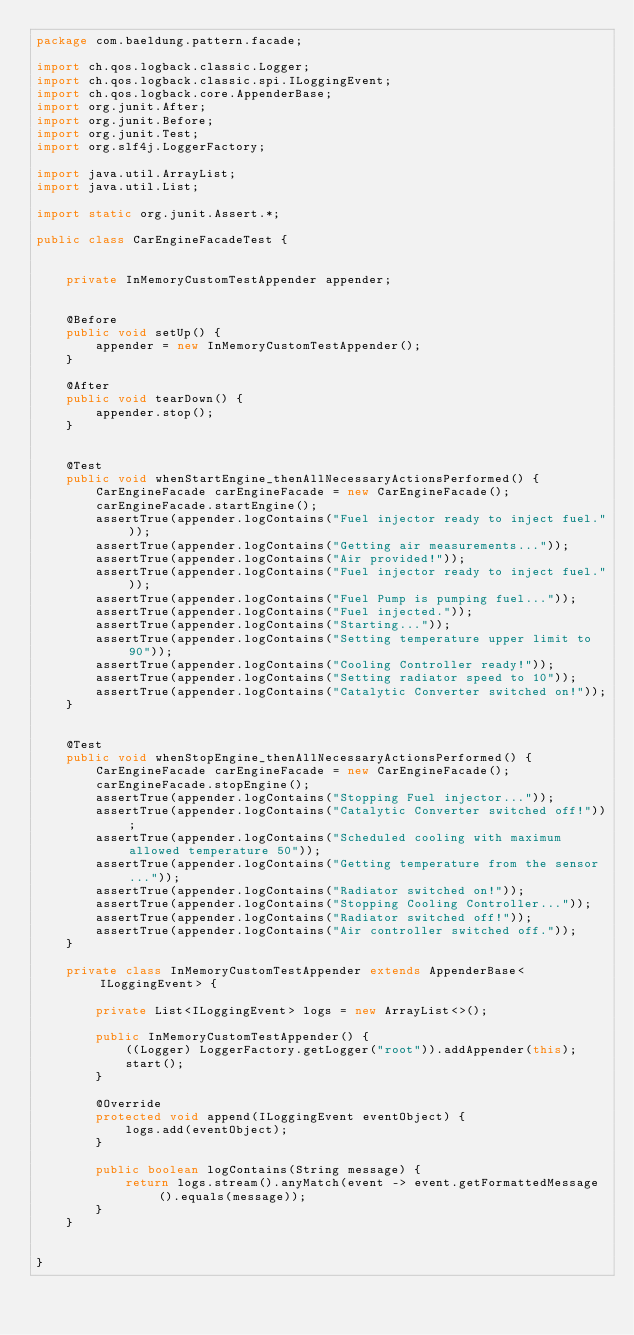<code> <loc_0><loc_0><loc_500><loc_500><_Java_>package com.baeldung.pattern.facade;

import ch.qos.logback.classic.Logger;
import ch.qos.logback.classic.spi.ILoggingEvent;
import ch.qos.logback.core.AppenderBase;
import org.junit.After;
import org.junit.Before;
import org.junit.Test;
import org.slf4j.LoggerFactory;

import java.util.ArrayList;
import java.util.List;

import static org.junit.Assert.*;

public class CarEngineFacadeTest {


    private InMemoryCustomTestAppender appender;


    @Before
    public void setUp() {
        appender = new InMemoryCustomTestAppender();
    }

    @After
    public void tearDown() {
        appender.stop();
    }


    @Test
    public void whenStartEngine_thenAllNecessaryActionsPerformed() {
        CarEngineFacade carEngineFacade = new CarEngineFacade();
        carEngineFacade.startEngine();
        assertTrue(appender.logContains("Fuel injector ready to inject fuel."));
        assertTrue(appender.logContains("Getting air measurements..."));
        assertTrue(appender.logContains("Air provided!"));
        assertTrue(appender.logContains("Fuel injector ready to inject fuel."));
        assertTrue(appender.logContains("Fuel Pump is pumping fuel..."));
        assertTrue(appender.logContains("Fuel injected."));
        assertTrue(appender.logContains("Starting..."));
        assertTrue(appender.logContains("Setting temperature upper limit to 90"));
        assertTrue(appender.logContains("Cooling Controller ready!"));
        assertTrue(appender.logContains("Setting radiator speed to 10"));
        assertTrue(appender.logContains("Catalytic Converter switched on!"));
    }


    @Test
    public void whenStopEngine_thenAllNecessaryActionsPerformed() {
        CarEngineFacade carEngineFacade = new CarEngineFacade();
        carEngineFacade.stopEngine();
        assertTrue(appender.logContains("Stopping Fuel injector..."));
        assertTrue(appender.logContains("Catalytic Converter switched off!"));
        assertTrue(appender.logContains("Scheduled cooling with maximum allowed temperature 50"));
        assertTrue(appender.logContains("Getting temperature from the sensor..."));
        assertTrue(appender.logContains("Radiator switched on!"));
        assertTrue(appender.logContains("Stopping Cooling Controller..."));
        assertTrue(appender.logContains("Radiator switched off!"));
        assertTrue(appender.logContains("Air controller switched off."));
    }

    private class InMemoryCustomTestAppender extends AppenderBase<ILoggingEvent> {

        private List<ILoggingEvent> logs = new ArrayList<>();

        public InMemoryCustomTestAppender() {
            ((Logger) LoggerFactory.getLogger("root")).addAppender(this);
            start();
        }

        @Override
        protected void append(ILoggingEvent eventObject) {
            logs.add(eventObject);
        }

        public boolean logContains(String message) {
            return logs.stream().anyMatch(event -> event.getFormattedMessage().equals(message));
        }
    }


}</code> 